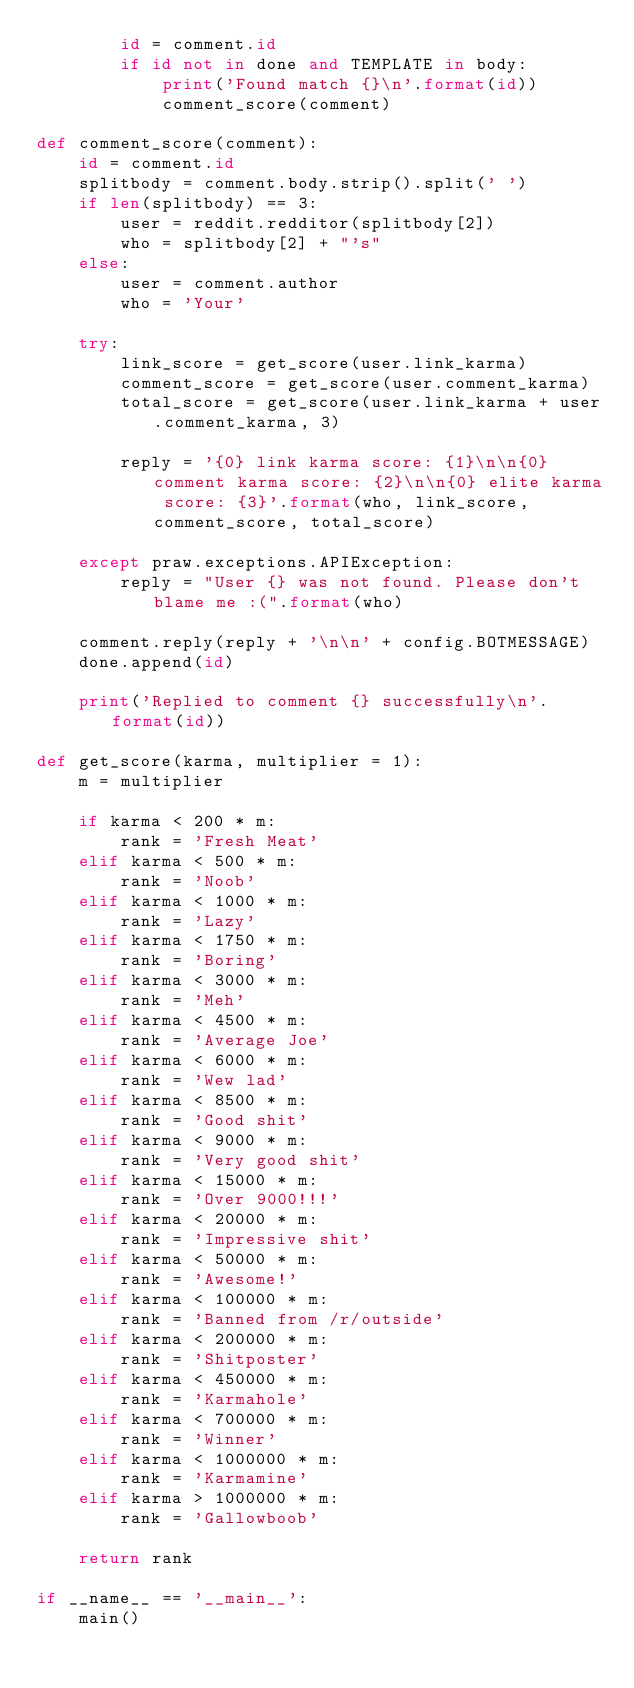<code> <loc_0><loc_0><loc_500><loc_500><_Python_>        id = comment.id
        if id not in done and TEMPLATE in body:
            print('Found match {}\n'.format(id))
            comment_score(comment)
            
def comment_score(comment):
    id = comment.id
    splitbody = comment.body.strip().split(' ')
    if len(splitbody) == 3:
        user = reddit.redditor(splitbody[2])
        who = splitbody[2] + "'s"
    else:
        user = comment.author
        who = 'Your'
            
    try:
        link_score = get_score(user.link_karma)
        comment_score = get_score(user.comment_karma)
        total_score = get_score(user.link_karma + user.comment_karma, 3)
                
        reply = '{0} link karma score: {1}\n\n{0} comment karma score: {2}\n\n{0} elite karma score: {3}'.format(who, link_score, comment_score, total_score)
            
    except praw.exceptions.APIException:
        reply = "User {} was not found. Please don't blame me :(".format(who)
            
    comment.reply(reply + '\n\n' + config.BOTMESSAGE)
    done.append(id)
        
    print('Replied to comment {} successfully\n'.format(id))
    
def get_score(karma, multiplier = 1):
    m = multiplier
    
    if karma < 200 * m:
        rank = 'Fresh Meat'
    elif karma < 500 * m:
        rank = 'Noob'
    elif karma < 1000 * m:
        rank = 'Lazy'
    elif karma < 1750 * m:
        rank = 'Boring'
    elif karma < 3000 * m:
        rank = 'Meh'
    elif karma < 4500 * m:
        rank = 'Average Joe'
    elif karma < 6000 * m:
        rank = 'Wew lad'
    elif karma < 8500 * m:
        rank = 'Good shit'
    elif karma < 9000 * m:
        rank = 'Very good shit'
    elif karma < 15000 * m:
        rank = 'Over 9000!!!'
    elif karma < 20000 * m:
        rank = 'Impressive shit'
    elif karma < 50000 * m:
        rank = 'Awesome!'
    elif karma < 100000 * m:
        rank = 'Banned from /r/outside'
    elif karma < 200000 * m:
        rank = 'Shitposter'
    elif karma < 450000 * m:
        rank = 'Karmahole'
    elif karma < 700000 * m:
        rank = 'Winner'
    elif karma < 1000000 * m:
        rank = 'Karmamine'
    elif karma > 1000000 * m:
        rank = 'Gallowboob'
        
    return rank

if __name__ == '__main__':
    main()</code> 